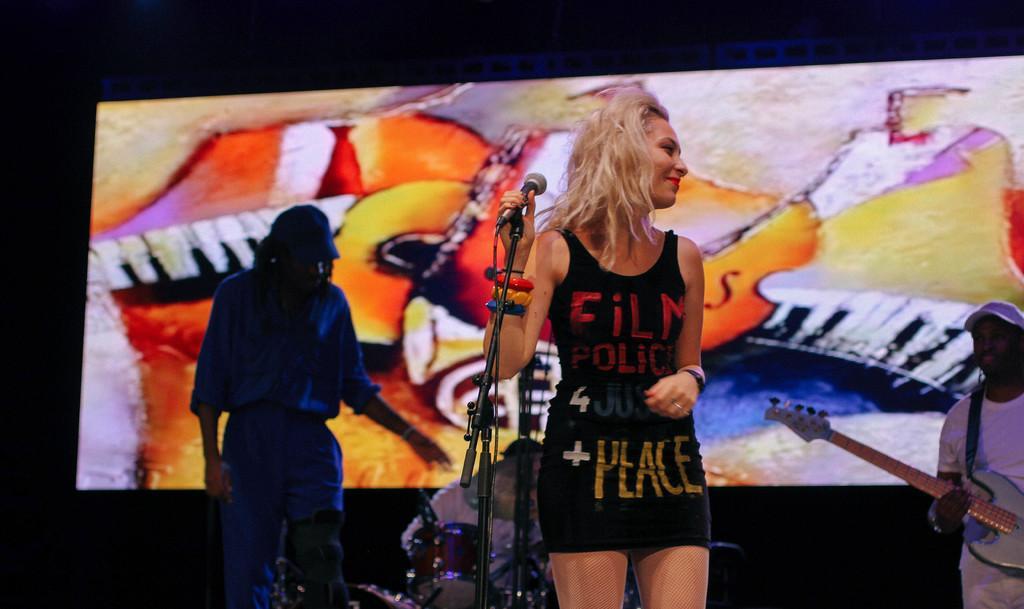Can you describe this image briefly? In this image we can see a woman holding the mike and standing and also smiling. In the background we can see two persons playing the musical instruments and also a person standing. We can also see the screen and the background of the image is in black color. 